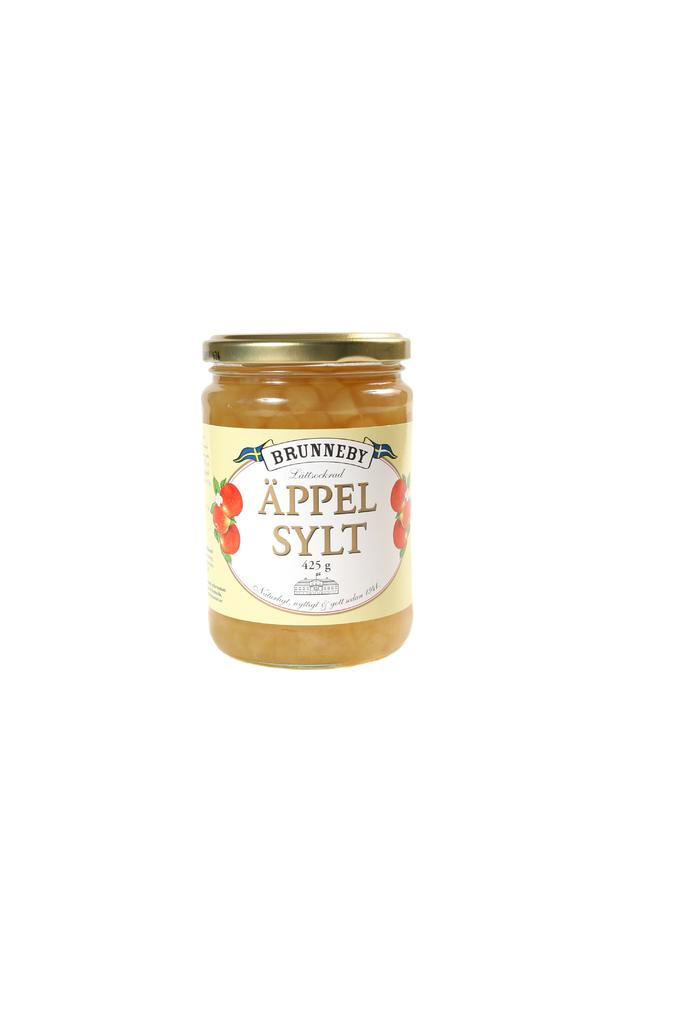What object is present in the image that can hold a liquid? There is a bottle in the image. What can be found on the surface of the bottle? The bottle has text and images on it. What is the price of the pan in the image? There is no pan present in the image, so it is not possible to determine its price. 